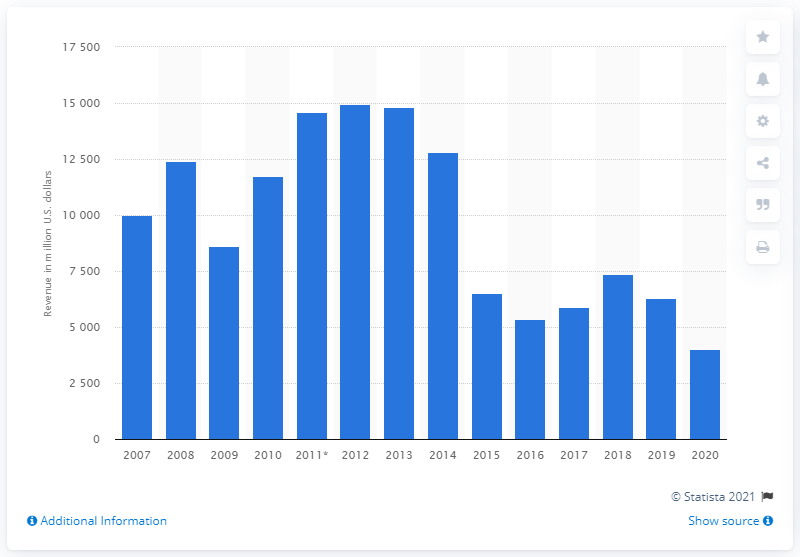Point out several critical features in this image. Apache Corporation's revenue in the year prior to the specified date was 6,315. 